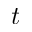Convert formula to latex. <formula><loc_0><loc_0><loc_500><loc_500>t</formula> 